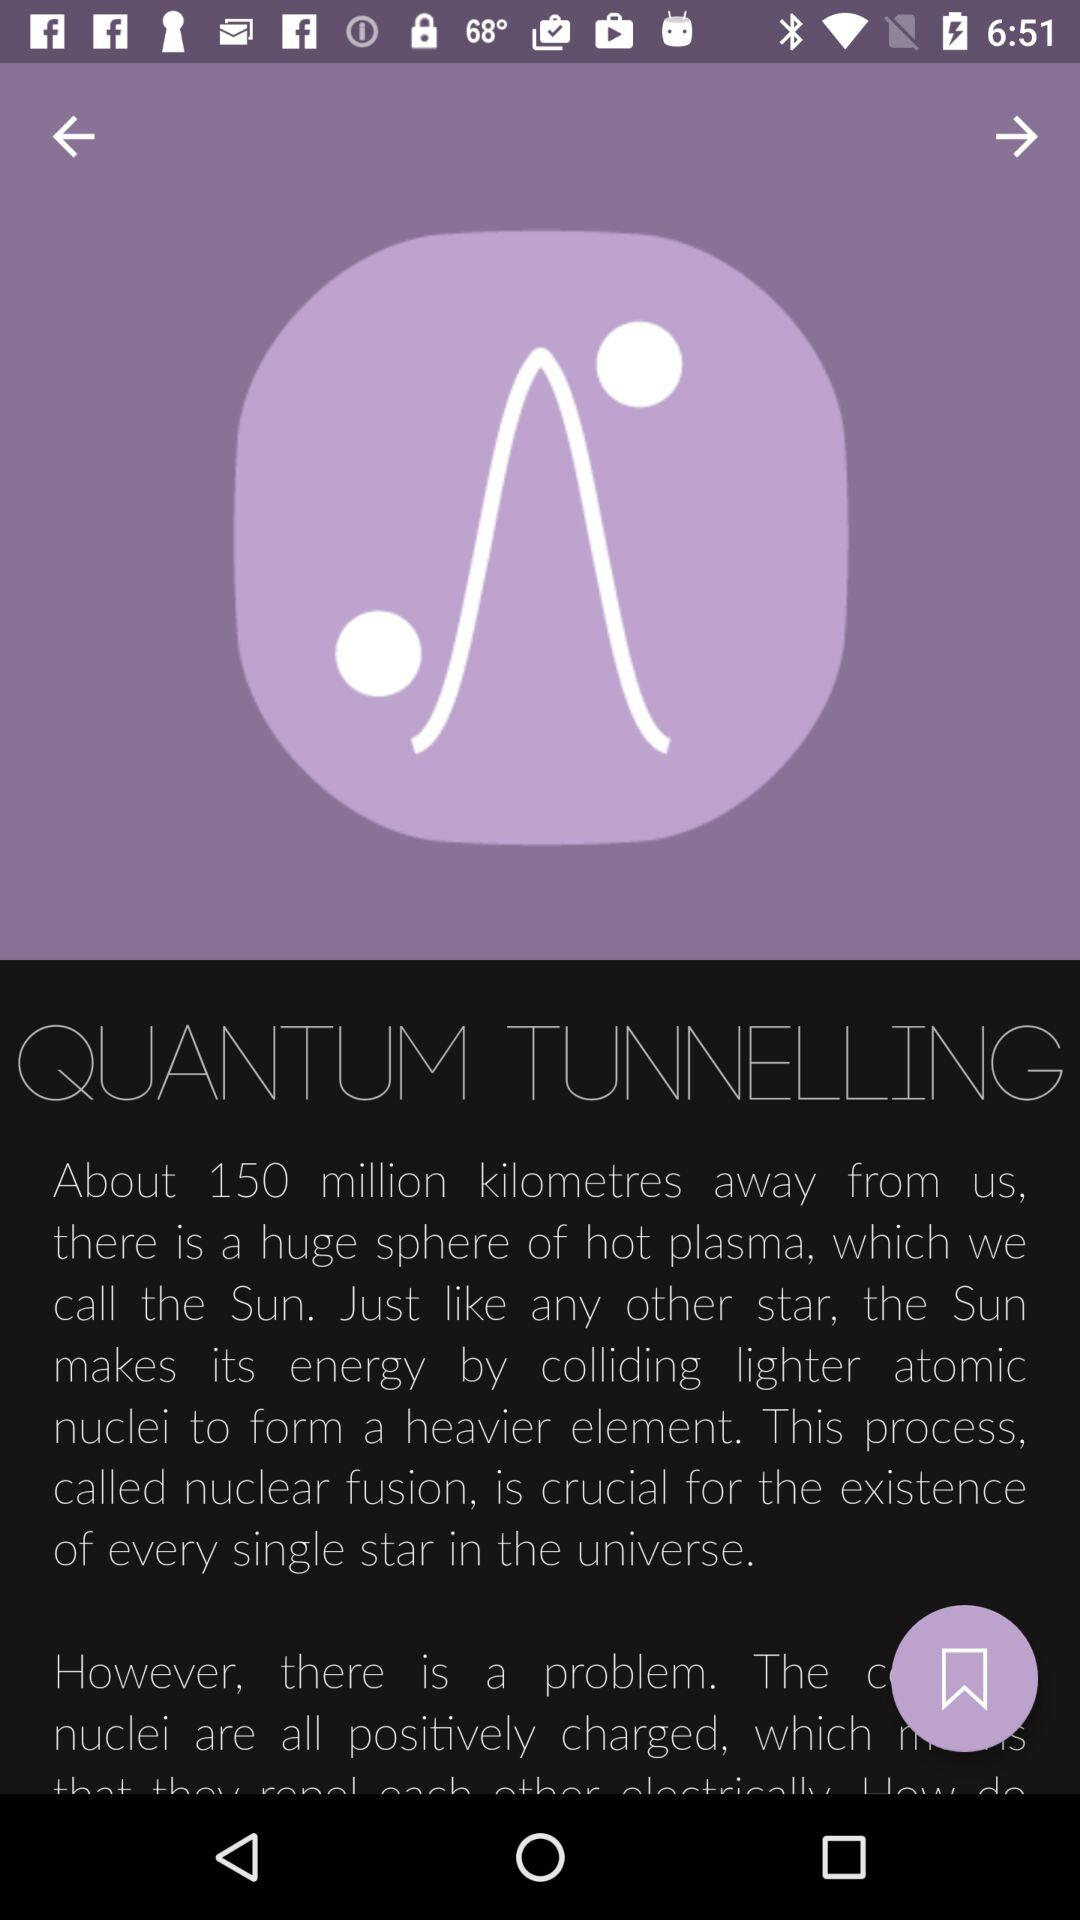How far is the sun? The sun is 150 million kilometres away from us. 